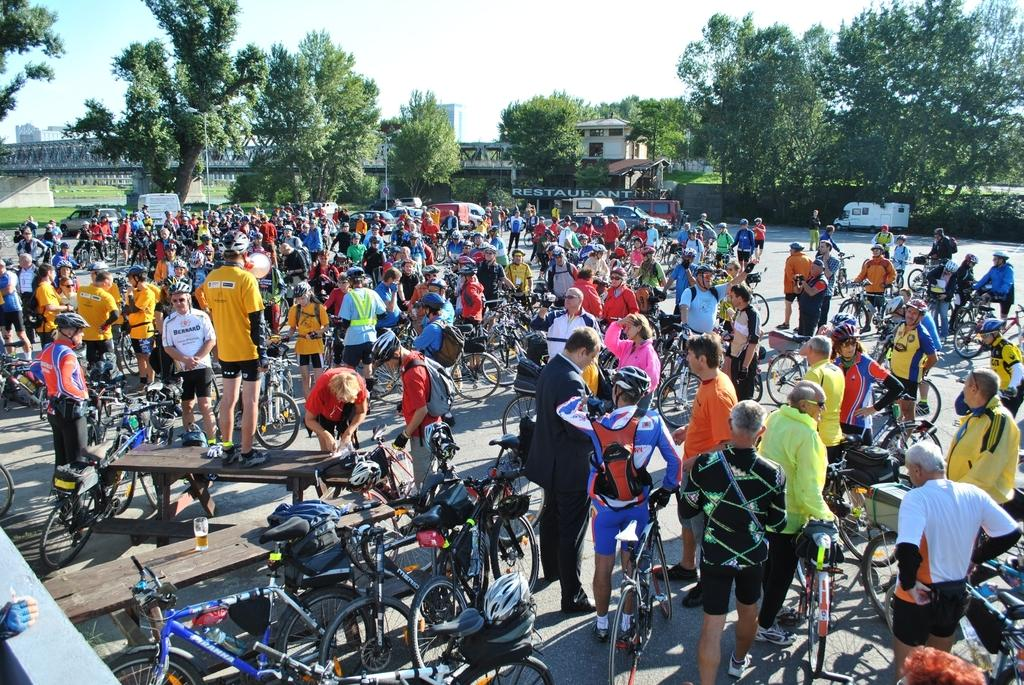How many people are in the group visible in the image? There is a group of people in the image, but the exact number cannot be determined from the provided facts. What are the people in the image doing? The provided facts do not specify what the people in the image are doing. What can be seen in the image besides the group of people? There are bicycles visible in the image. What is visible in the background of the image? In the background of the image, there are vehicles, trees, poles, buildings, and a bridge. What type of plant is growing on the bridge in the image? There is no plant growing on the bridge in the image; the bridge is visible in the background, but no plants are mentioned in the provided facts. How many cherries are on the trees in the image? There is no mention of cherries in the provided facts, so it cannot be determined how many cherries might be on the trees in the image. 